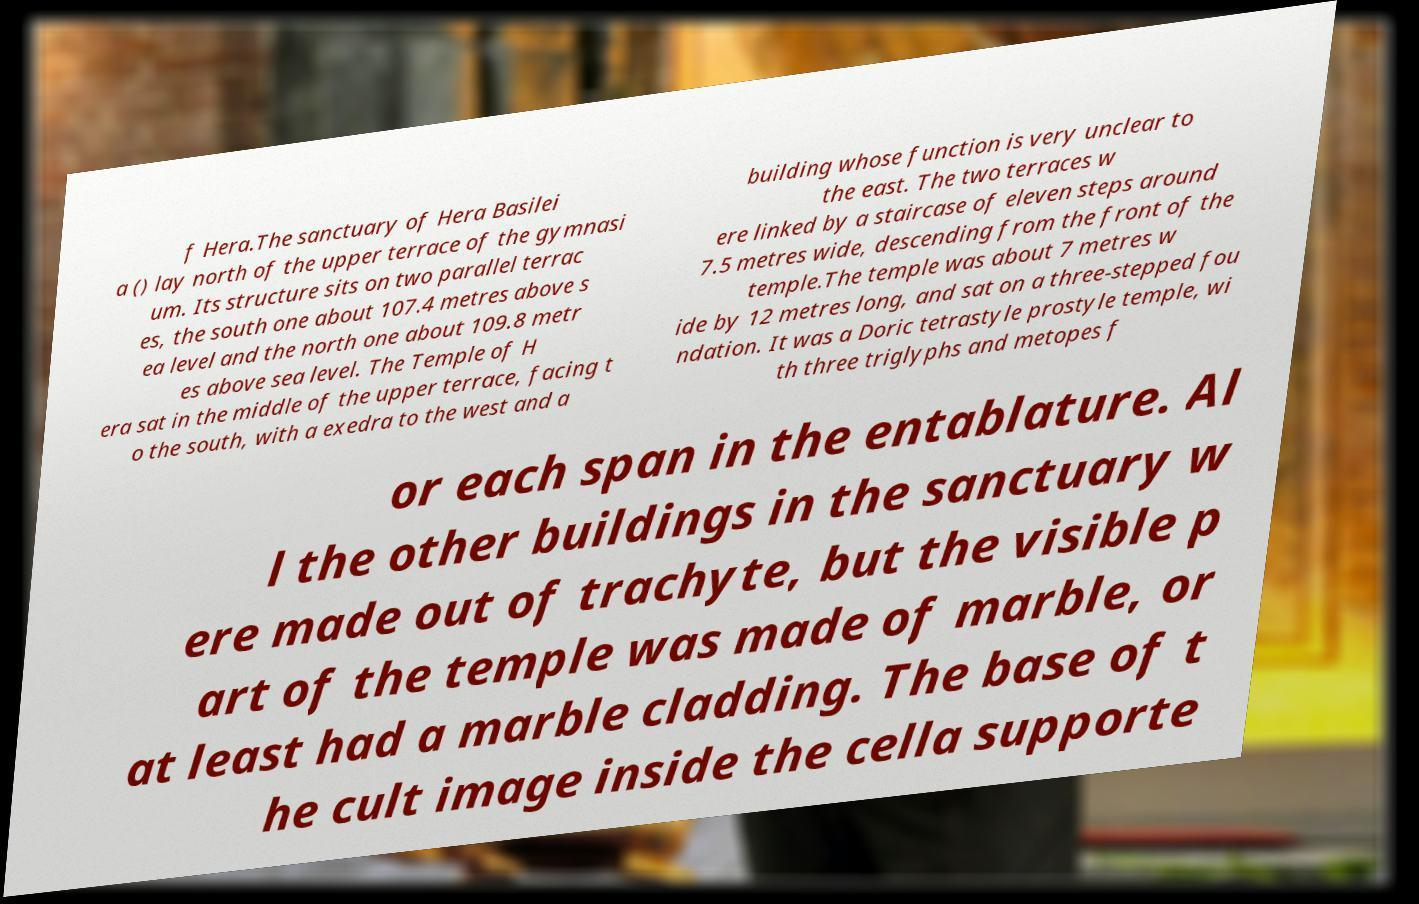Can you accurately transcribe the text from the provided image for me? f Hera.The sanctuary of Hera Basilei a () lay north of the upper terrace of the gymnasi um. Its structure sits on two parallel terrac es, the south one about 107.4 metres above s ea level and the north one about 109.8 metr es above sea level. The Temple of H era sat in the middle of the upper terrace, facing t o the south, with a exedra to the west and a building whose function is very unclear to the east. The two terraces w ere linked by a staircase of eleven steps around 7.5 metres wide, descending from the front of the temple.The temple was about 7 metres w ide by 12 metres long, and sat on a three-stepped fou ndation. It was a Doric tetrastyle prostyle temple, wi th three triglyphs and metopes f or each span in the entablature. Al l the other buildings in the sanctuary w ere made out of trachyte, but the visible p art of the temple was made of marble, or at least had a marble cladding. The base of t he cult image inside the cella supporte 